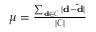Convert formula to latex. <formula><loc_0><loc_0><loc_500><loc_500>\begin{array} { r } { \mu = \frac { \sum _ { d \in \mathcal { C } } { | d - \hat { d } | } } { | \mathcal { C } | } } \end{array}</formula> 